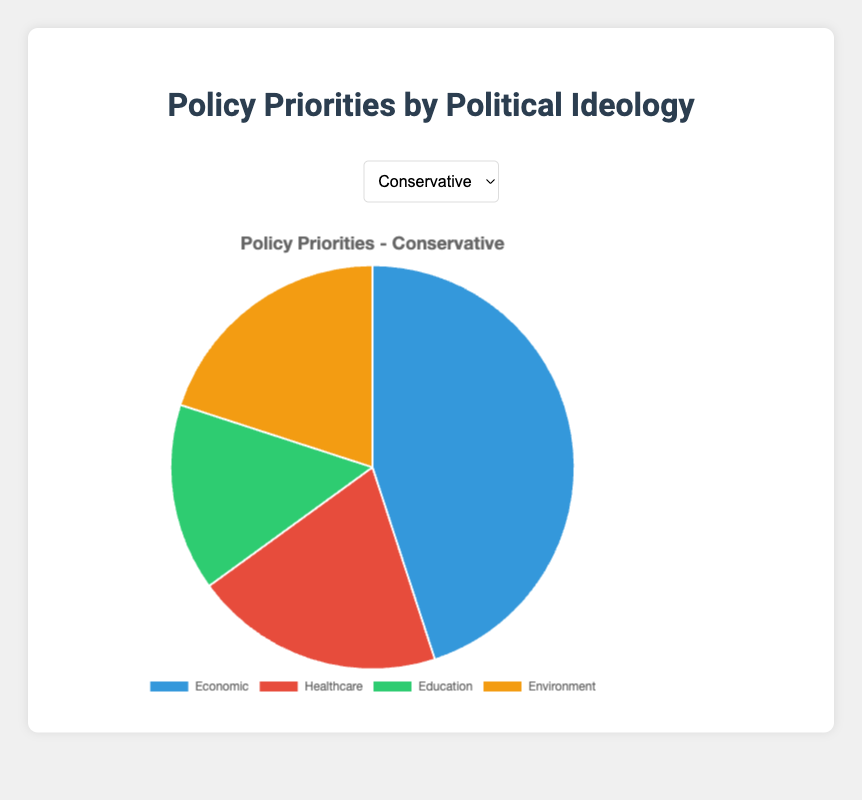Which policy issue is ranked highest by Conservatives? By looking at the pie chart for Conservatives, the sector with the largest slice represents the 'Economic' category.
Answer: Economic Which political ideology prioritizes the Environment the most? By examining each pie chart, the 'Green' ideology has the largest slice in the Environment sector.
Answer: Green What is the combined percentage for Healthcare and Education for Liberals? The values for Healthcare and Education for Liberals are 30% and 25%, respectively. Summing these two values gives us 30 + 25 = 55%.
Answer: 55% Compare the emphasis on Economic issues between Conservatives and Libertarians. Which group places more importance on this category? The Economic slice for Conservatives is 45%, while for Libertarians it is 60%. Libertarians place more importance on Economic issues.
Answer: Libertarians Which policy issue is given the least priority by the Green ideology? By looking at the pie chart for Green, the smallest slice represents the 'Economic' category.
Answer: Economic For Conservatives, what is the difference in percentage points between the most important and the least important policy issue? The most important issue for Conservatives is Economic (45%) and the least important is Education (15%). The difference is 45 - 15 = 30 percentage points.
Answer: 30 percentage points What is the visual clue that indicates the relative importance of policy issues for a particular ideology? The size of each slice in the pie chart represents the relative importance, with larger slices indicating higher importance.
Answer: Slice size How many ideologies have equal priority for Healthcare and Environment? By examining each pie chart, the Liberal ideology has equal slices for Healthcare and Environment, both at 25%.
Answer: One (Liberal) Which ideology gives more importance to Education, Liberal or Libertarian? By comparing the pie charts, Liberal ideology assigns 25% to Education, while Libertarian assigns 10%. Liberal gives more importance to Education.
Answer: Liberal What percentage of the Green ideology’s priorities are not focused on the Environment? The Green ideology assigns 60% to Environment. Therefore, 100% - 60% = 40% of their priorities are focused on other issues (Economic, Healthcare, and Education).
Answer: 40% 